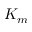<formula> <loc_0><loc_0><loc_500><loc_500>K _ { m }</formula> 